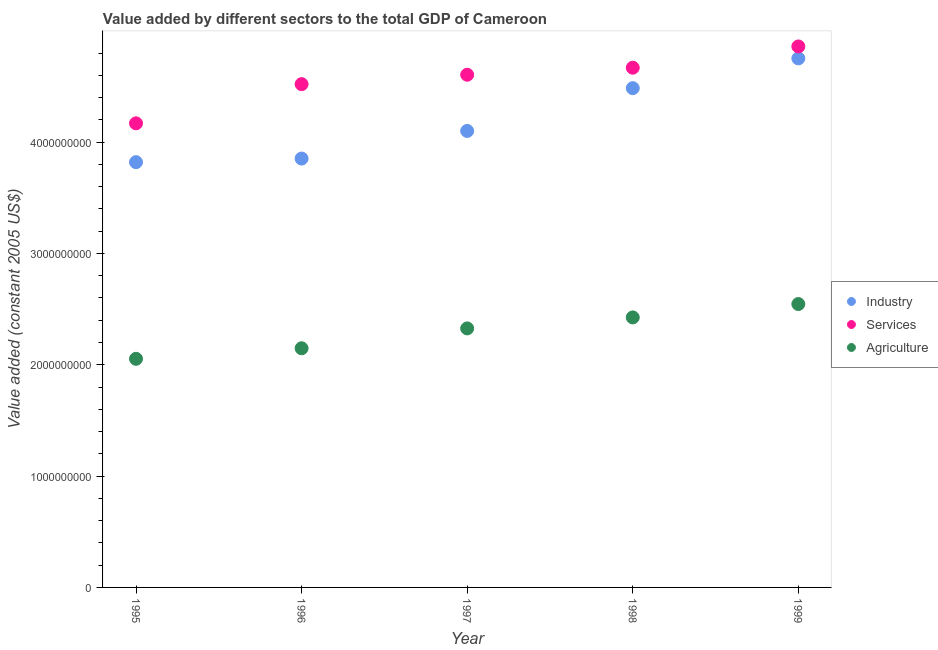How many different coloured dotlines are there?
Give a very brief answer. 3. Is the number of dotlines equal to the number of legend labels?
Offer a terse response. Yes. What is the value added by agricultural sector in 1997?
Provide a succinct answer. 2.33e+09. Across all years, what is the maximum value added by agricultural sector?
Provide a succinct answer. 2.55e+09. Across all years, what is the minimum value added by services?
Offer a terse response. 4.17e+09. In which year was the value added by services maximum?
Offer a terse response. 1999. What is the total value added by agricultural sector in the graph?
Offer a terse response. 1.15e+1. What is the difference between the value added by services in 1995 and that in 1999?
Give a very brief answer. -6.91e+08. What is the difference between the value added by agricultural sector in 1997 and the value added by services in 1998?
Provide a succinct answer. -2.34e+09. What is the average value added by services per year?
Ensure brevity in your answer.  4.56e+09. In the year 1995, what is the difference between the value added by industrial sector and value added by agricultural sector?
Keep it short and to the point. 1.77e+09. What is the ratio of the value added by agricultural sector in 1995 to that in 1996?
Provide a short and direct response. 0.96. Is the value added by agricultural sector in 1998 less than that in 1999?
Offer a terse response. Yes. Is the difference between the value added by agricultural sector in 1996 and 1998 greater than the difference between the value added by services in 1996 and 1998?
Offer a very short reply. No. What is the difference between the highest and the second highest value added by agricultural sector?
Your answer should be very brief. 1.20e+08. What is the difference between the highest and the lowest value added by industrial sector?
Ensure brevity in your answer.  9.32e+08. In how many years, is the value added by agricultural sector greater than the average value added by agricultural sector taken over all years?
Ensure brevity in your answer.  3. Is the sum of the value added by agricultural sector in 1996 and 1998 greater than the maximum value added by services across all years?
Ensure brevity in your answer.  No. Does the value added by industrial sector monotonically increase over the years?
Ensure brevity in your answer.  Yes. Is the value added by industrial sector strictly greater than the value added by agricultural sector over the years?
Keep it short and to the point. Yes. How many dotlines are there?
Your response must be concise. 3. Are the values on the major ticks of Y-axis written in scientific E-notation?
Ensure brevity in your answer.  No. What is the title of the graph?
Your answer should be compact. Value added by different sectors to the total GDP of Cameroon. What is the label or title of the Y-axis?
Provide a succinct answer. Value added (constant 2005 US$). What is the Value added (constant 2005 US$) of Industry in 1995?
Give a very brief answer. 3.82e+09. What is the Value added (constant 2005 US$) of Services in 1995?
Your response must be concise. 4.17e+09. What is the Value added (constant 2005 US$) in Agriculture in 1995?
Ensure brevity in your answer.  2.05e+09. What is the Value added (constant 2005 US$) in Industry in 1996?
Your response must be concise. 3.85e+09. What is the Value added (constant 2005 US$) of Services in 1996?
Your response must be concise. 4.52e+09. What is the Value added (constant 2005 US$) of Agriculture in 1996?
Ensure brevity in your answer.  2.15e+09. What is the Value added (constant 2005 US$) of Industry in 1997?
Make the answer very short. 4.10e+09. What is the Value added (constant 2005 US$) of Services in 1997?
Make the answer very short. 4.61e+09. What is the Value added (constant 2005 US$) of Agriculture in 1997?
Give a very brief answer. 2.33e+09. What is the Value added (constant 2005 US$) in Industry in 1998?
Keep it short and to the point. 4.48e+09. What is the Value added (constant 2005 US$) in Services in 1998?
Offer a very short reply. 4.67e+09. What is the Value added (constant 2005 US$) of Agriculture in 1998?
Your answer should be very brief. 2.43e+09. What is the Value added (constant 2005 US$) in Industry in 1999?
Your answer should be very brief. 4.75e+09. What is the Value added (constant 2005 US$) of Services in 1999?
Your answer should be very brief. 4.86e+09. What is the Value added (constant 2005 US$) of Agriculture in 1999?
Your answer should be very brief. 2.55e+09. Across all years, what is the maximum Value added (constant 2005 US$) of Industry?
Your answer should be compact. 4.75e+09. Across all years, what is the maximum Value added (constant 2005 US$) of Services?
Keep it short and to the point. 4.86e+09. Across all years, what is the maximum Value added (constant 2005 US$) of Agriculture?
Keep it short and to the point. 2.55e+09. Across all years, what is the minimum Value added (constant 2005 US$) of Industry?
Make the answer very short. 3.82e+09. Across all years, what is the minimum Value added (constant 2005 US$) of Services?
Ensure brevity in your answer.  4.17e+09. Across all years, what is the minimum Value added (constant 2005 US$) in Agriculture?
Your response must be concise. 2.05e+09. What is the total Value added (constant 2005 US$) of Industry in the graph?
Give a very brief answer. 2.10e+1. What is the total Value added (constant 2005 US$) in Services in the graph?
Ensure brevity in your answer.  2.28e+1. What is the total Value added (constant 2005 US$) of Agriculture in the graph?
Your answer should be compact. 1.15e+1. What is the difference between the Value added (constant 2005 US$) in Industry in 1995 and that in 1996?
Provide a short and direct response. -3.23e+07. What is the difference between the Value added (constant 2005 US$) of Services in 1995 and that in 1996?
Your answer should be compact. -3.52e+08. What is the difference between the Value added (constant 2005 US$) in Agriculture in 1995 and that in 1996?
Keep it short and to the point. -9.46e+07. What is the difference between the Value added (constant 2005 US$) of Industry in 1995 and that in 1997?
Provide a succinct answer. -2.80e+08. What is the difference between the Value added (constant 2005 US$) of Services in 1995 and that in 1997?
Your response must be concise. -4.36e+08. What is the difference between the Value added (constant 2005 US$) in Agriculture in 1995 and that in 1997?
Provide a succinct answer. -2.73e+08. What is the difference between the Value added (constant 2005 US$) of Industry in 1995 and that in 1998?
Offer a very short reply. -6.65e+08. What is the difference between the Value added (constant 2005 US$) of Services in 1995 and that in 1998?
Keep it short and to the point. -5.00e+08. What is the difference between the Value added (constant 2005 US$) in Agriculture in 1995 and that in 1998?
Your answer should be very brief. -3.72e+08. What is the difference between the Value added (constant 2005 US$) of Industry in 1995 and that in 1999?
Make the answer very short. -9.32e+08. What is the difference between the Value added (constant 2005 US$) in Services in 1995 and that in 1999?
Provide a succinct answer. -6.91e+08. What is the difference between the Value added (constant 2005 US$) of Agriculture in 1995 and that in 1999?
Offer a very short reply. -4.92e+08. What is the difference between the Value added (constant 2005 US$) of Industry in 1996 and that in 1997?
Provide a short and direct response. -2.48e+08. What is the difference between the Value added (constant 2005 US$) of Services in 1996 and that in 1997?
Make the answer very short. -8.45e+07. What is the difference between the Value added (constant 2005 US$) in Agriculture in 1996 and that in 1997?
Give a very brief answer. -1.78e+08. What is the difference between the Value added (constant 2005 US$) of Industry in 1996 and that in 1998?
Ensure brevity in your answer.  -6.32e+08. What is the difference between the Value added (constant 2005 US$) in Services in 1996 and that in 1998?
Your answer should be compact. -1.48e+08. What is the difference between the Value added (constant 2005 US$) in Agriculture in 1996 and that in 1998?
Your answer should be compact. -2.77e+08. What is the difference between the Value added (constant 2005 US$) of Industry in 1996 and that in 1999?
Provide a short and direct response. -9.00e+08. What is the difference between the Value added (constant 2005 US$) in Services in 1996 and that in 1999?
Give a very brief answer. -3.39e+08. What is the difference between the Value added (constant 2005 US$) in Agriculture in 1996 and that in 1999?
Provide a succinct answer. -3.97e+08. What is the difference between the Value added (constant 2005 US$) of Industry in 1997 and that in 1998?
Your response must be concise. -3.84e+08. What is the difference between the Value added (constant 2005 US$) in Services in 1997 and that in 1998?
Make the answer very short. -6.31e+07. What is the difference between the Value added (constant 2005 US$) in Agriculture in 1997 and that in 1998?
Keep it short and to the point. -9.88e+07. What is the difference between the Value added (constant 2005 US$) of Industry in 1997 and that in 1999?
Your answer should be compact. -6.52e+08. What is the difference between the Value added (constant 2005 US$) of Services in 1997 and that in 1999?
Your response must be concise. -2.54e+08. What is the difference between the Value added (constant 2005 US$) of Agriculture in 1997 and that in 1999?
Make the answer very short. -2.19e+08. What is the difference between the Value added (constant 2005 US$) of Industry in 1998 and that in 1999?
Your answer should be very brief. -2.67e+08. What is the difference between the Value added (constant 2005 US$) of Services in 1998 and that in 1999?
Keep it short and to the point. -1.91e+08. What is the difference between the Value added (constant 2005 US$) in Agriculture in 1998 and that in 1999?
Make the answer very short. -1.20e+08. What is the difference between the Value added (constant 2005 US$) of Industry in 1995 and the Value added (constant 2005 US$) of Services in 1996?
Make the answer very short. -7.01e+08. What is the difference between the Value added (constant 2005 US$) of Industry in 1995 and the Value added (constant 2005 US$) of Agriculture in 1996?
Offer a very short reply. 1.67e+09. What is the difference between the Value added (constant 2005 US$) in Services in 1995 and the Value added (constant 2005 US$) in Agriculture in 1996?
Your response must be concise. 2.02e+09. What is the difference between the Value added (constant 2005 US$) in Industry in 1995 and the Value added (constant 2005 US$) in Services in 1997?
Offer a terse response. -7.85e+08. What is the difference between the Value added (constant 2005 US$) in Industry in 1995 and the Value added (constant 2005 US$) in Agriculture in 1997?
Offer a terse response. 1.49e+09. What is the difference between the Value added (constant 2005 US$) in Services in 1995 and the Value added (constant 2005 US$) in Agriculture in 1997?
Make the answer very short. 1.84e+09. What is the difference between the Value added (constant 2005 US$) in Industry in 1995 and the Value added (constant 2005 US$) in Services in 1998?
Ensure brevity in your answer.  -8.49e+08. What is the difference between the Value added (constant 2005 US$) of Industry in 1995 and the Value added (constant 2005 US$) of Agriculture in 1998?
Make the answer very short. 1.39e+09. What is the difference between the Value added (constant 2005 US$) of Services in 1995 and the Value added (constant 2005 US$) of Agriculture in 1998?
Your response must be concise. 1.74e+09. What is the difference between the Value added (constant 2005 US$) in Industry in 1995 and the Value added (constant 2005 US$) in Services in 1999?
Your response must be concise. -1.04e+09. What is the difference between the Value added (constant 2005 US$) of Industry in 1995 and the Value added (constant 2005 US$) of Agriculture in 1999?
Provide a succinct answer. 1.27e+09. What is the difference between the Value added (constant 2005 US$) in Services in 1995 and the Value added (constant 2005 US$) in Agriculture in 1999?
Offer a very short reply. 1.62e+09. What is the difference between the Value added (constant 2005 US$) in Industry in 1996 and the Value added (constant 2005 US$) in Services in 1997?
Make the answer very short. -7.53e+08. What is the difference between the Value added (constant 2005 US$) of Industry in 1996 and the Value added (constant 2005 US$) of Agriculture in 1997?
Offer a terse response. 1.53e+09. What is the difference between the Value added (constant 2005 US$) of Services in 1996 and the Value added (constant 2005 US$) of Agriculture in 1997?
Offer a terse response. 2.19e+09. What is the difference between the Value added (constant 2005 US$) of Industry in 1996 and the Value added (constant 2005 US$) of Services in 1998?
Ensure brevity in your answer.  -8.16e+08. What is the difference between the Value added (constant 2005 US$) in Industry in 1996 and the Value added (constant 2005 US$) in Agriculture in 1998?
Your answer should be very brief. 1.43e+09. What is the difference between the Value added (constant 2005 US$) in Services in 1996 and the Value added (constant 2005 US$) in Agriculture in 1998?
Make the answer very short. 2.10e+09. What is the difference between the Value added (constant 2005 US$) in Industry in 1996 and the Value added (constant 2005 US$) in Services in 1999?
Your answer should be very brief. -1.01e+09. What is the difference between the Value added (constant 2005 US$) of Industry in 1996 and the Value added (constant 2005 US$) of Agriculture in 1999?
Provide a short and direct response. 1.31e+09. What is the difference between the Value added (constant 2005 US$) of Services in 1996 and the Value added (constant 2005 US$) of Agriculture in 1999?
Offer a terse response. 1.98e+09. What is the difference between the Value added (constant 2005 US$) of Industry in 1997 and the Value added (constant 2005 US$) of Services in 1998?
Provide a succinct answer. -5.68e+08. What is the difference between the Value added (constant 2005 US$) of Industry in 1997 and the Value added (constant 2005 US$) of Agriculture in 1998?
Give a very brief answer. 1.68e+09. What is the difference between the Value added (constant 2005 US$) in Services in 1997 and the Value added (constant 2005 US$) in Agriculture in 1998?
Provide a succinct answer. 2.18e+09. What is the difference between the Value added (constant 2005 US$) of Industry in 1997 and the Value added (constant 2005 US$) of Services in 1999?
Make the answer very short. -7.59e+08. What is the difference between the Value added (constant 2005 US$) of Industry in 1997 and the Value added (constant 2005 US$) of Agriculture in 1999?
Ensure brevity in your answer.  1.55e+09. What is the difference between the Value added (constant 2005 US$) of Services in 1997 and the Value added (constant 2005 US$) of Agriculture in 1999?
Offer a very short reply. 2.06e+09. What is the difference between the Value added (constant 2005 US$) in Industry in 1998 and the Value added (constant 2005 US$) in Services in 1999?
Give a very brief answer. -3.75e+08. What is the difference between the Value added (constant 2005 US$) in Industry in 1998 and the Value added (constant 2005 US$) in Agriculture in 1999?
Your response must be concise. 1.94e+09. What is the difference between the Value added (constant 2005 US$) of Services in 1998 and the Value added (constant 2005 US$) of Agriculture in 1999?
Keep it short and to the point. 2.12e+09. What is the average Value added (constant 2005 US$) in Industry per year?
Your response must be concise. 4.20e+09. What is the average Value added (constant 2005 US$) in Services per year?
Give a very brief answer. 4.56e+09. What is the average Value added (constant 2005 US$) in Agriculture per year?
Keep it short and to the point. 2.30e+09. In the year 1995, what is the difference between the Value added (constant 2005 US$) in Industry and Value added (constant 2005 US$) in Services?
Offer a terse response. -3.49e+08. In the year 1995, what is the difference between the Value added (constant 2005 US$) in Industry and Value added (constant 2005 US$) in Agriculture?
Give a very brief answer. 1.77e+09. In the year 1995, what is the difference between the Value added (constant 2005 US$) of Services and Value added (constant 2005 US$) of Agriculture?
Give a very brief answer. 2.12e+09. In the year 1996, what is the difference between the Value added (constant 2005 US$) in Industry and Value added (constant 2005 US$) in Services?
Give a very brief answer. -6.69e+08. In the year 1996, what is the difference between the Value added (constant 2005 US$) of Industry and Value added (constant 2005 US$) of Agriculture?
Make the answer very short. 1.70e+09. In the year 1996, what is the difference between the Value added (constant 2005 US$) of Services and Value added (constant 2005 US$) of Agriculture?
Your answer should be compact. 2.37e+09. In the year 1997, what is the difference between the Value added (constant 2005 US$) in Industry and Value added (constant 2005 US$) in Services?
Your answer should be very brief. -5.05e+08. In the year 1997, what is the difference between the Value added (constant 2005 US$) of Industry and Value added (constant 2005 US$) of Agriculture?
Provide a short and direct response. 1.77e+09. In the year 1997, what is the difference between the Value added (constant 2005 US$) in Services and Value added (constant 2005 US$) in Agriculture?
Offer a very short reply. 2.28e+09. In the year 1998, what is the difference between the Value added (constant 2005 US$) of Industry and Value added (constant 2005 US$) of Services?
Make the answer very short. -1.84e+08. In the year 1998, what is the difference between the Value added (constant 2005 US$) of Industry and Value added (constant 2005 US$) of Agriculture?
Your response must be concise. 2.06e+09. In the year 1998, what is the difference between the Value added (constant 2005 US$) of Services and Value added (constant 2005 US$) of Agriculture?
Provide a short and direct response. 2.24e+09. In the year 1999, what is the difference between the Value added (constant 2005 US$) of Industry and Value added (constant 2005 US$) of Services?
Offer a terse response. -1.07e+08. In the year 1999, what is the difference between the Value added (constant 2005 US$) of Industry and Value added (constant 2005 US$) of Agriculture?
Your response must be concise. 2.21e+09. In the year 1999, what is the difference between the Value added (constant 2005 US$) of Services and Value added (constant 2005 US$) of Agriculture?
Your response must be concise. 2.31e+09. What is the ratio of the Value added (constant 2005 US$) of Services in 1995 to that in 1996?
Keep it short and to the point. 0.92. What is the ratio of the Value added (constant 2005 US$) in Agriculture in 1995 to that in 1996?
Offer a very short reply. 0.96. What is the ratio of the Value added (constant 2005 US$) in Industry in 1995 to that in 1997?
Your answer should be compact. 0.93. What is the ratio of the Value added (constant 2005 US$) in Services in 1995 to that in 1997?
Give a very brief answer. 0.91. What is the ratio of the Value added (constant 2005 US$) in Agriculture in 1995 to that in 1997?
Make the answer very short. 0.88. What is the ratio of the Value added (constant 2005 US$) of Industry in 1995 to that in 1998?
Your answer should be very brief. 0.85. What is the ratio of the Value added (constant 2005 US$) in Services in 1995 to that in 1998?
Your answer should be very brief. 0.89. What is the ratio of the Value added (constant 2005 US$) of Agriculture in 1995 to that in 1998?
Offer a very short reply. 0.85. What is the ratio of the Value added (constant 2005 US$) in Industry in 1995 to that in 1999?
Keep it short and to the point. 0.8. What is the ratio of the Value added (constant 2005 US$) of Services in 1995 to that in 1999?
Provide a short and direct response. 0.86. What is the ratio of the Value added (constant 2005 US$) of Agriculture in 1995 to that in 1999?
Offer a terse response. 0.81. What is the ratio of the Value added (constant 2005 US$) in Industry in 1996 to that in 1997?
Provide a succinct answer. 0.94. What is the ratio of the Value added (constant 2005 US$) of Services in 1996 to that in 1997?
Keep it short and to the point. 0.98. What is the ratio of the Value added (constant 2005 US$) of Agriculture in 1996 to that in 1997?
Your answer should be very brief. 0.92. What is the ratio of the Value added (constant 2005 US$) of Industry in 1996 to that in 1998?
Your answer should be very brief. 0.86. What is the ratio of the Value added (constant 2005 US$) of Services in 1996 to that in 1998?
Make the answer very short. 0.97. What is the ratio of the Value added (constant 2005 US$) of Agriculture in 1996 to that in 1998?
Make the answer very short. 0.89. What is the ratio of the Value added (constant 2005 US$) of Industry in 1996 to that in 1999?
Your answer should be very brief. 0.81. What is the ratio of the Value added (constant 2005 US$) of Services in 1996 to that in 1999?
Provide a short and direct response. 0.93. What is the ratio of the Value added (constant 2005 US$) in Agriculture in 1996 to that in 1999?
Keep it short and to the point. 0.84. What is the ratio of the Value added (constant 2005 US$) in Industry in 1997 to that in 1998?
Your response must be concise. 0.91. What is the ratio of the Value added (constant 2005 US$) in Services in 1997 to that in 1998?
Your response must be concise. 0.99. What is the ratio of the Value added (constant 2005 US$) in Agriculture in 1997 to that in 1998?
Ensure brevity in your answer.  0.96. What is the ratio of the Value added (constant 2005 US$) in Industry in 1997 to that in 1999?
Give a very brief answer. 0.86. What is the ratio of the Value added (constant 2005 US$) of Services in 1997 to that in 1999?
Offer a terse response. 0.95. What is the ratio of the Value added (constant 2005 US$) in Agriculture in 1997 to that in 1999?
Provide a short and direct response. 0.91. What is the ratio of the Value added (constant 2005 US$) of Industry in 1998 to that in 1999?
Your answer should be very brief. 0.94. What is the ratio of the Value added (constant 2005 US$) of Services in 1998 to that in 1999?
Your response must be concise. 0.96. What is the ratio of the Value added (constant 2005 US$) of Agriculture in 1998 to that in 1999?
Ensure brevity in your answer.  0.95. What is the difference between the highest and the second highest Value added (constant 2005 US$) in Industry?
Offer a very short reply. 2.67e+08. What is the difference between the highest and the second highest Value added (constant 2005 US$) in Services?
Your answer should be very brief. 1.91e+08. What is the difference between the highest and the second highest Value added (constant 2005 US$) in Agriculture?
Provide a succinct answer. 1.20e+08. What is the difference between the highest and the lowest Value added (constant 2005 US$) of Industry?
Your answer should be very brief. 9.32e+08. What is the difference between the highest and the lowest Value added (constant 2005 US$) of Services?
Offer a very short reply. 6.91e+08. What is the difference between the highest and the lowest Value added (constant 2005 US$) of Agriculture?
Provide a short and direct response. 4.92e+08. 